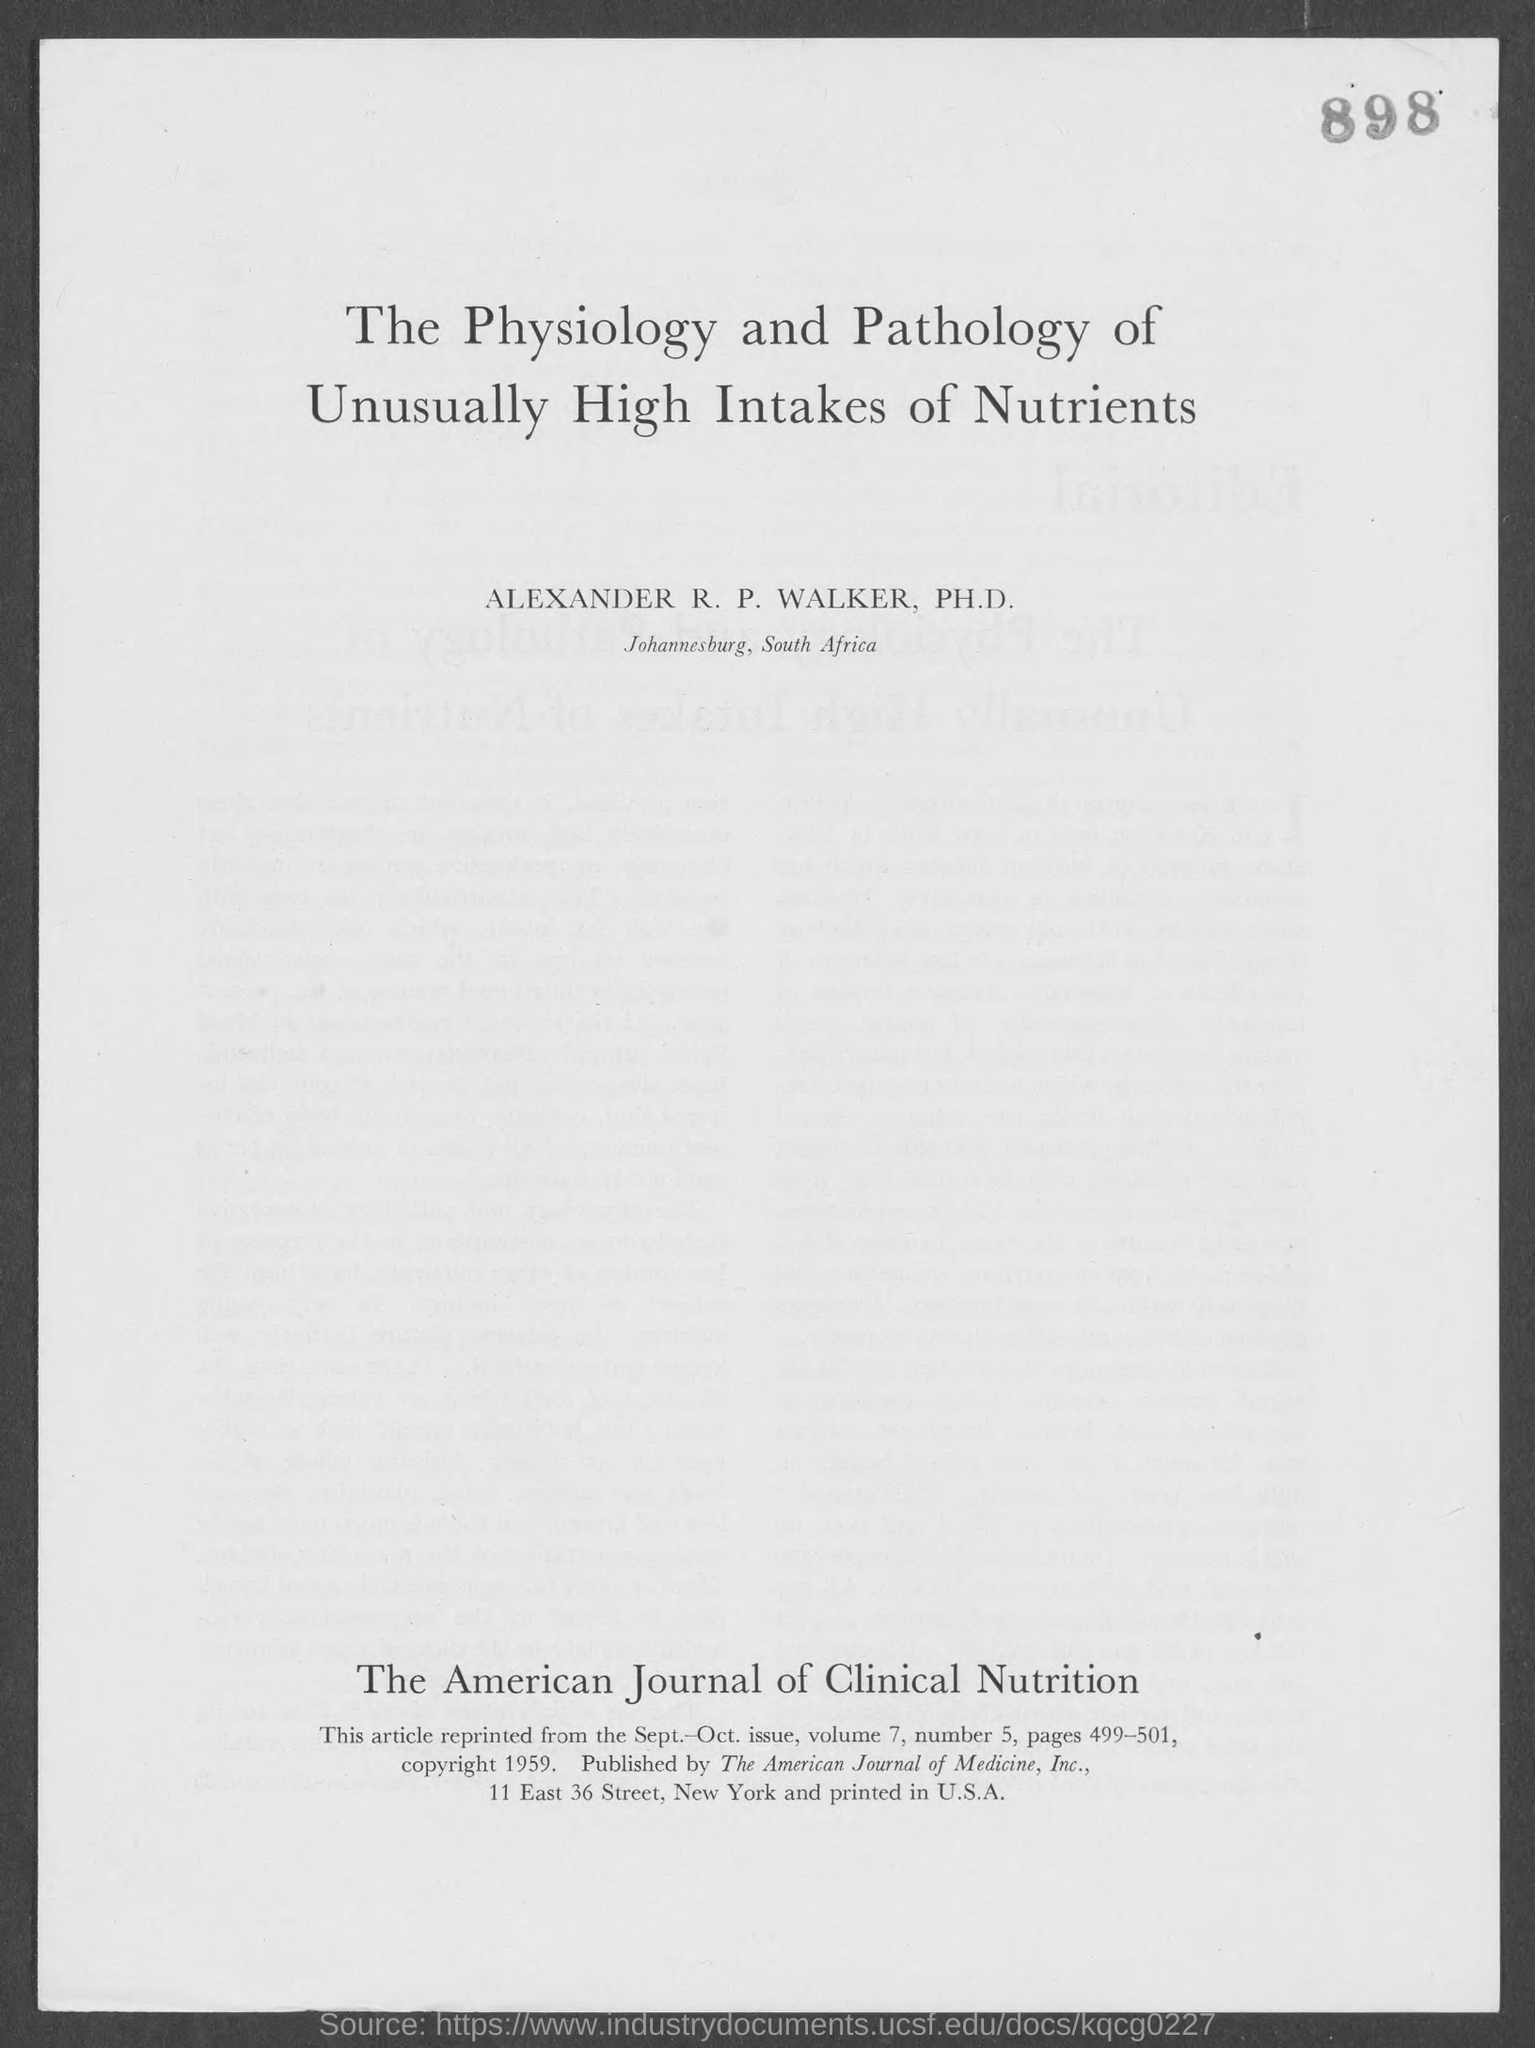Indicate a few pertinent items in this graphic. The volume is 7. The number is 5. The article is a reprint from the September-October issue. The pages 499-501 contain... 